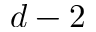<formula> <loc_0><loc_0><loc_500><loc_500>d - 2</formula> 